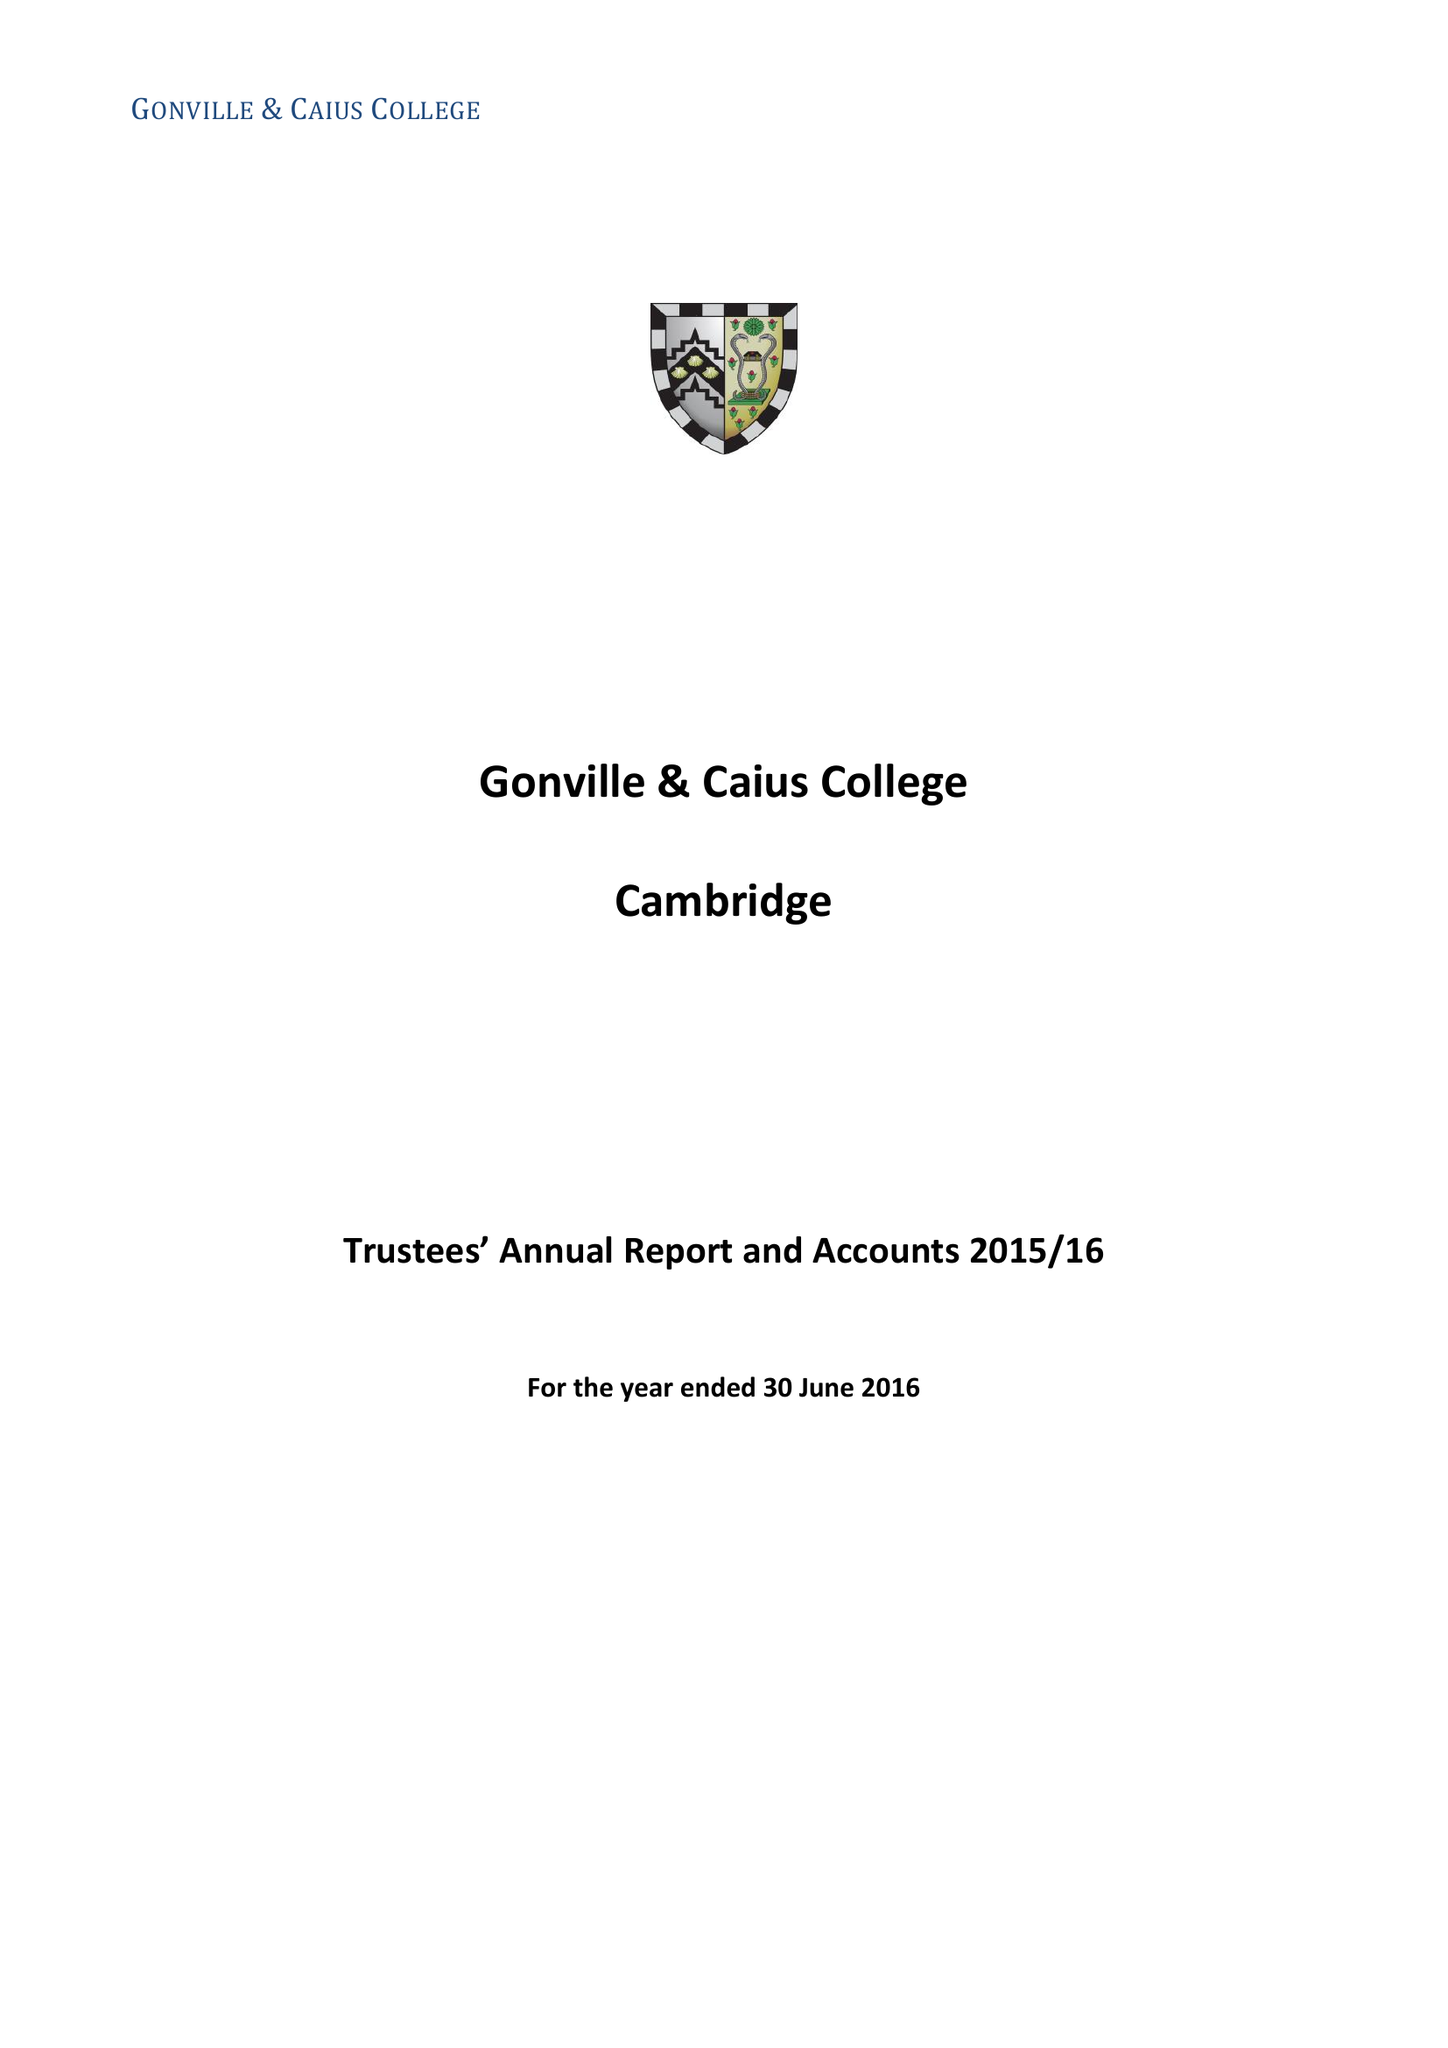What is the value for the income_annually_in_british_pounds?
Answer the question using a single word or phrase. 21137190.00 